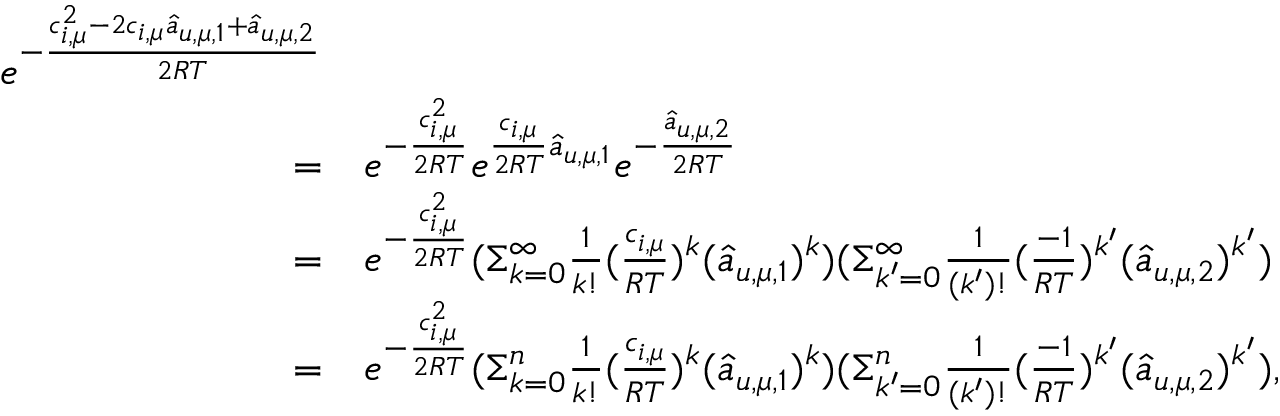Convert formula to latex. <formula><loc_0><loc_0><loc_500><loc_500>\begin{array} { r l } { e ^ { - \frac { c _ { i , \mu } ^ { 2 } - 2 c _ { i , \mu } \hat { a } _ { u , \mu , 1 } + \hat { a } _ { u , \mu , 2 } } { 2 R T } } } \\ { = } & e ^ { - \frac { c _ { i , \mu } ^ { 2 } } { 2 R T } } e ^ { \frac { c _ { i , \mu } } { 2 R T } \hat { a } _ { u , \mu , 1 } } e ^ { - \frac { \hat { a } _ { u , \mu , 2 } } { 2 R T } } } \\ { = } & e ^ { - \frac { c _ { i , \mu } ^ { 2 } } { 2 R T } } ( \Sigma _ { k = 0 } ^ { \infty } \frac { 1 } { k ! } ( \frac { c _ { i , \mu } } { R T } ) ^ { k } ( \hat { a } _ { u , \mu , 1 } ) ^ { k } ) ( \Sigma _ { k ^ { \prime } = 0 } ^ { \infty } \frac { 1 } { ( k ^ { \prime } ) ! } ( \frac { - 1 } { R T } ) ^ { k ^ { \prime } } ( \hat { a } _ { u , \mu , 2 } ) ^ { k ^ { \prime } } ) } \\ { = } & e ^ { - \frac { c _ { i , \mu } ^ { 2 } } { 2 R T } } ( \Sigma _ { k = 0 } ^ { n } \frac { 1 } { k ! } ( \frac { c _ { i , \mu } } { R T } ) ^ { k } ( \hat { a } _ { u , \mu , 1 } ) ^ { k } ) ( \Sigma _ { k ^ { \prime } = 0 } ^ { n } \frac { 1 } { ( k ^ { \prime } ) ! } ( \frac { - 1 } { R T } ) ^ { k ^ { \prime } } ( \hat { a } _ { u , \mu , 2 } ) ^ { k ^ { \prime } } ) , } \end{array}</formula> 